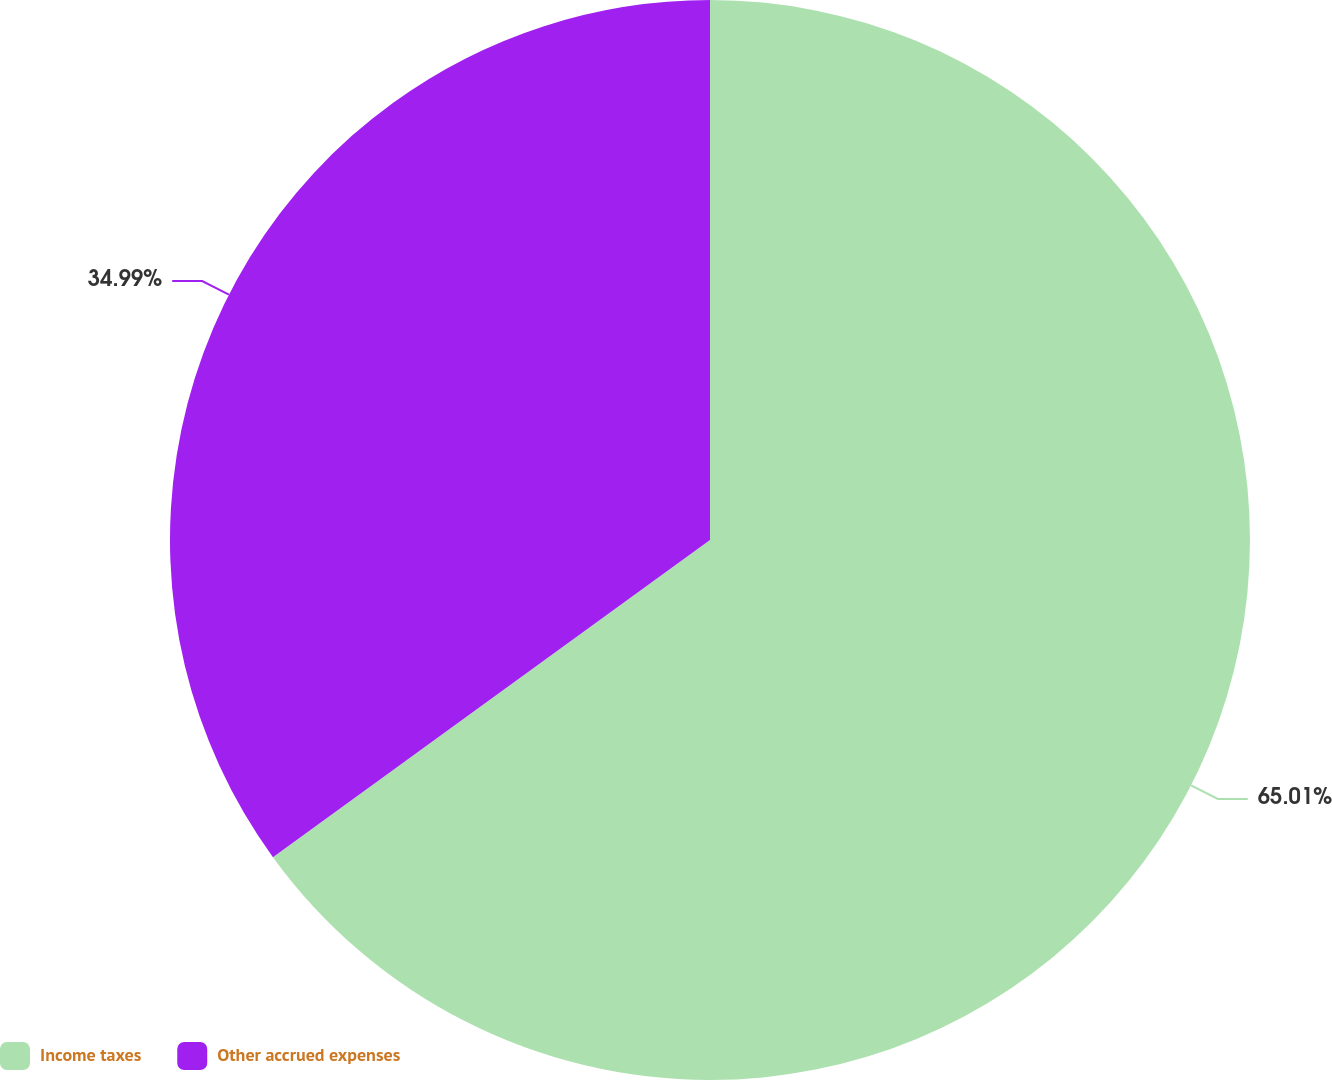Convert chart. <chart><loc_0><loc_0><loc_500><loc_500><pie_chart><fcel>Income taxes<fcel>Other accrued expenses<nl><fcel>65.01%<fcel>34.99%<nl></chart> 